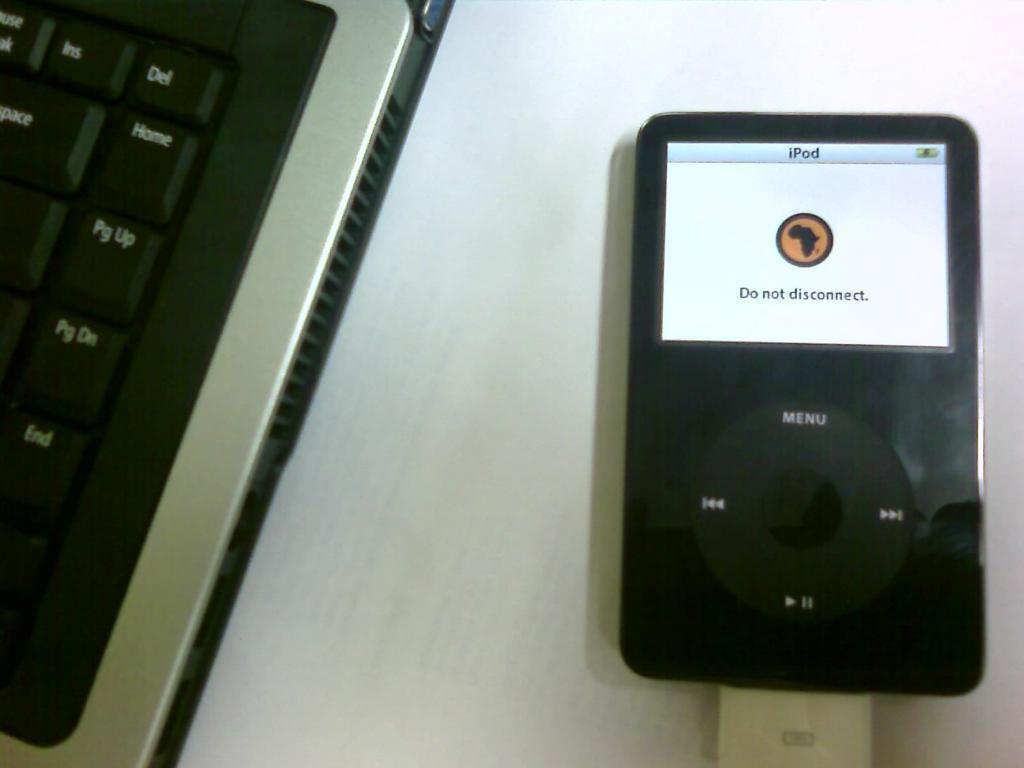In one or two sentences, can you explain what this image depicts? As we can see in the image there is a keyboard and iPod. 